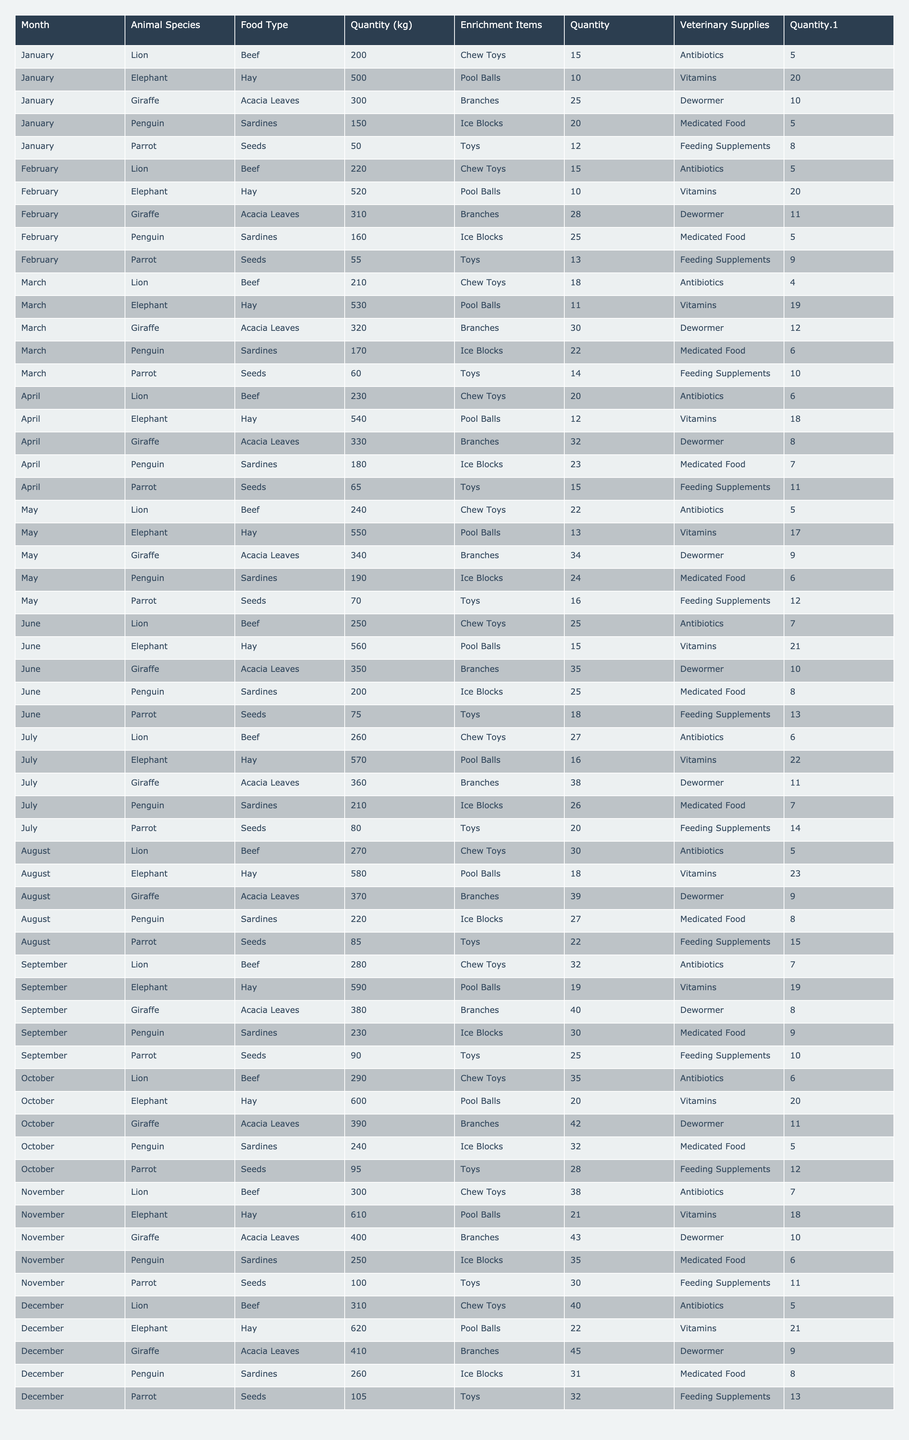What was the total quantity of beef fed to lions from January to December? In the table, add the values of beef for lions across all months: 200 + 220 + 210 + 230 + 240 + 250 + 260 + 270 + 280 + 290 + 300 + 310 = 3,180
Answer: 3,180 kg Which animal species had the highest quantity of food in May? Look at the food quantities in May: Lion (240 kg), Elephant (550 kg), Giraffe (340 kg), Penguin (190 kg), Parrot (70 kg). The highest is 550 kg for the Elephant.
Answer: Elephant Was the quantity of enrichment items for Giraffes consistent over the months? Observe the enrichment item quantities for Giraffes: 25, 28, 30, 32, 34, 35, 38, 39, 40, 42, 43, 45. These values are increasing each month, indicating inconsistency.
Answer: No What is the average quantity of Ice Blocks given to Penguins throughout the year? Sum the Ice Block quantities for Penguins: 20 + 25 + 22 + 23 + 24 + 25 + 26 + 27 + 30 + 32 + 35 + 31 =  305, then divide by 12, which gives an average of 25.42.
Answer: 25.42 Did the quantity of veterinary supplies for Elephants increase or decrease from January to December? Examine the veterinary supplies for Elephants over the months: 20, 20, 19, 18, 17, 21, 22, 23, 19, 20, 18, 21. The values fluctuate but end at 21, with a peak in August. Overall, there is no consistent increase.
Answer: No Which month had the highest total quantity of veterinary supplies across all animal species? Examine each month's total veterinary supplies: January (5 + 20 + 10 + 5 + 8), February (5 + 20 + 11 + 5 + 9), ... until December and find the maximum total quantity. December gives the largest total, which is 75.
Answer: December Calculate the difference between the highest and lowest quantity of food provided to Parrots over the year. The lowest is January (50 kg) and the highest is December (105 kg). The difference is 105 - 50 = 55.
Answer: 55 kg Did the Giraffe receive more enrichment items in December compared to January? The quantity of enrichment items for Giraffe in December is 45, while in January it was 25. Since 45 is greater than 25, Giraffe received more in December.
Answer: Yes 